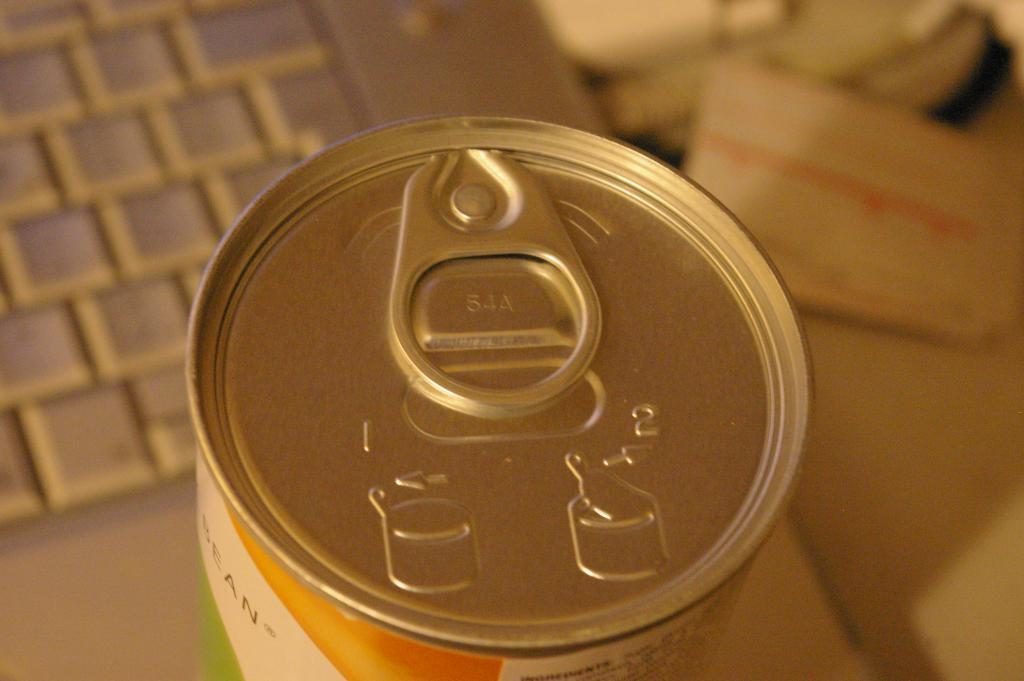What object is present in the image that is typically used for storing items? There is a tin in the image. What object is present in the image that is used for typing and inputting data? There is a keyboard in the image. Can you describe the background of the image? The background of the image is blurred. Where is the chicken located in the image? There is no chicken present in the image. What type of animal can be seen in the zoo in the image? There is no zoo or any animals present in the image. What type of furniture is visible in the image? There is no furniture, such as a sofa, present in the image. 